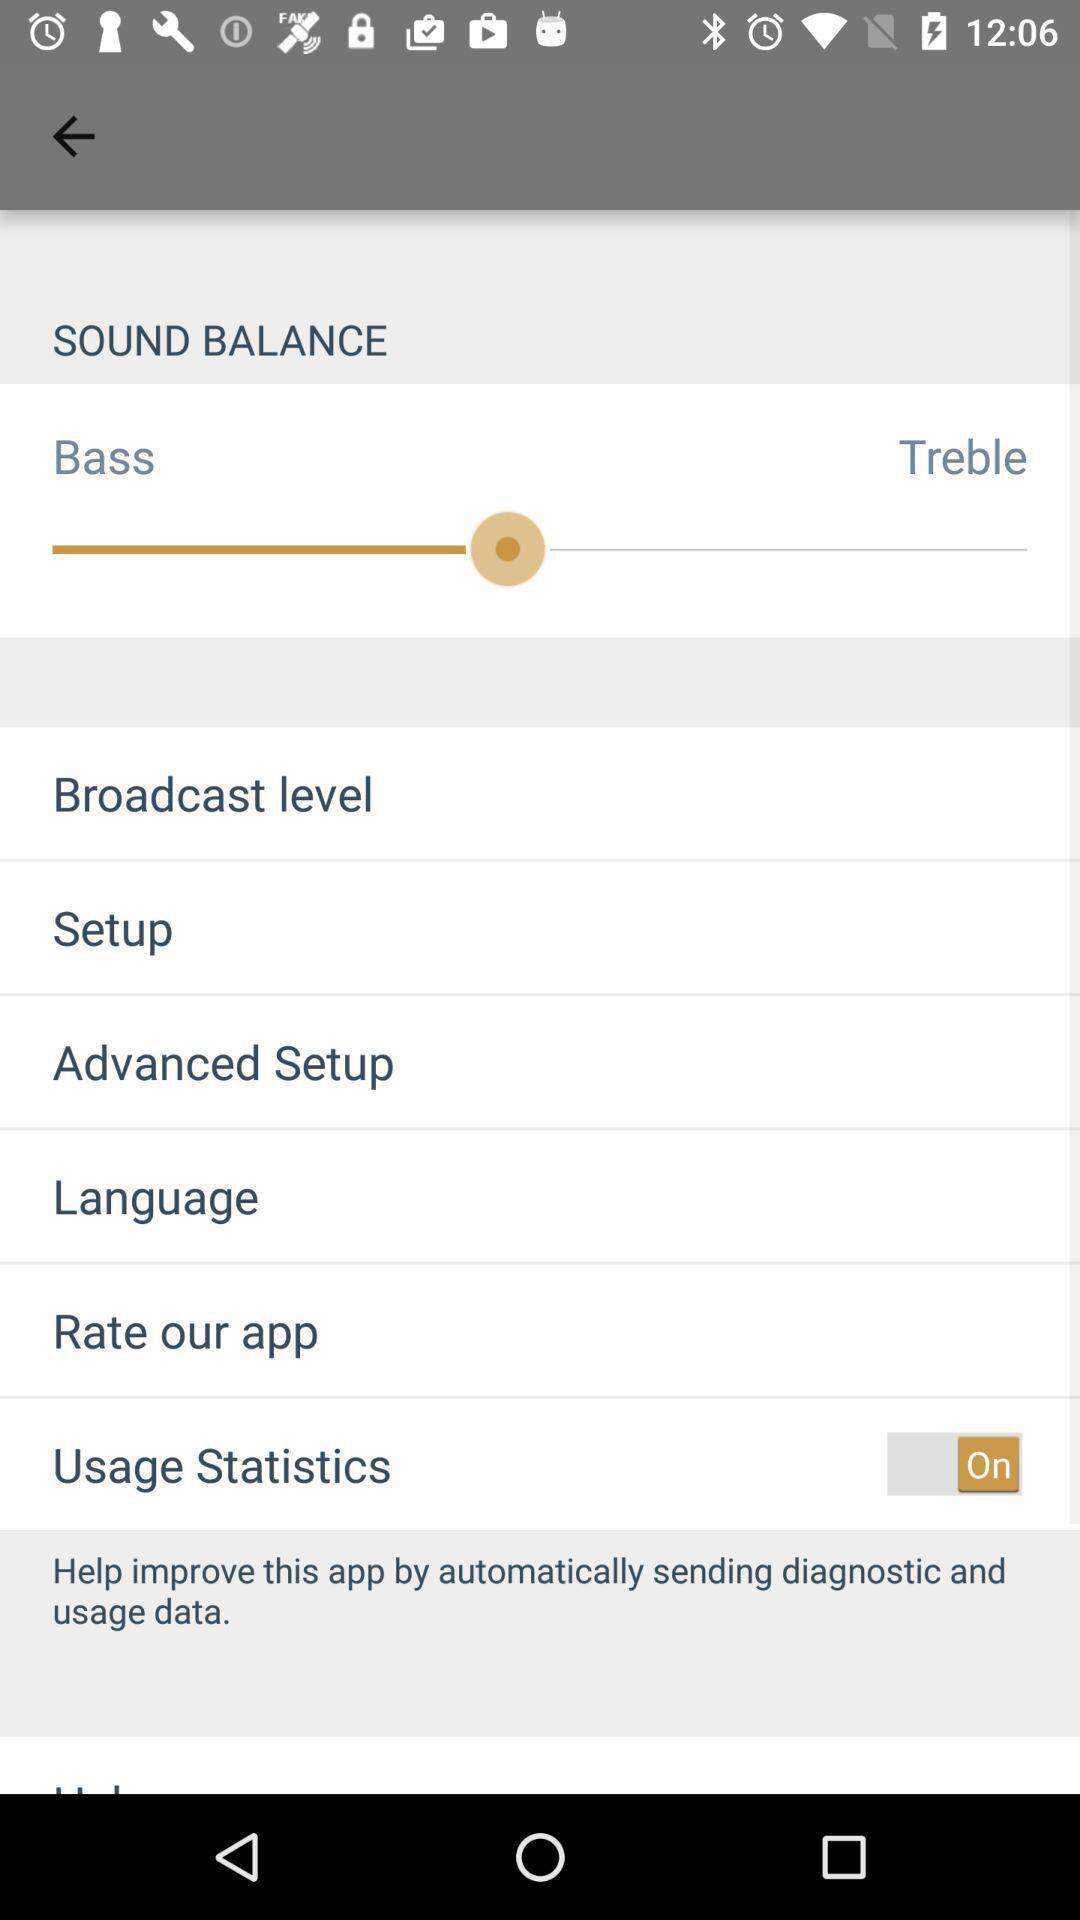Describe the key features of this screenshot. Settings page. 